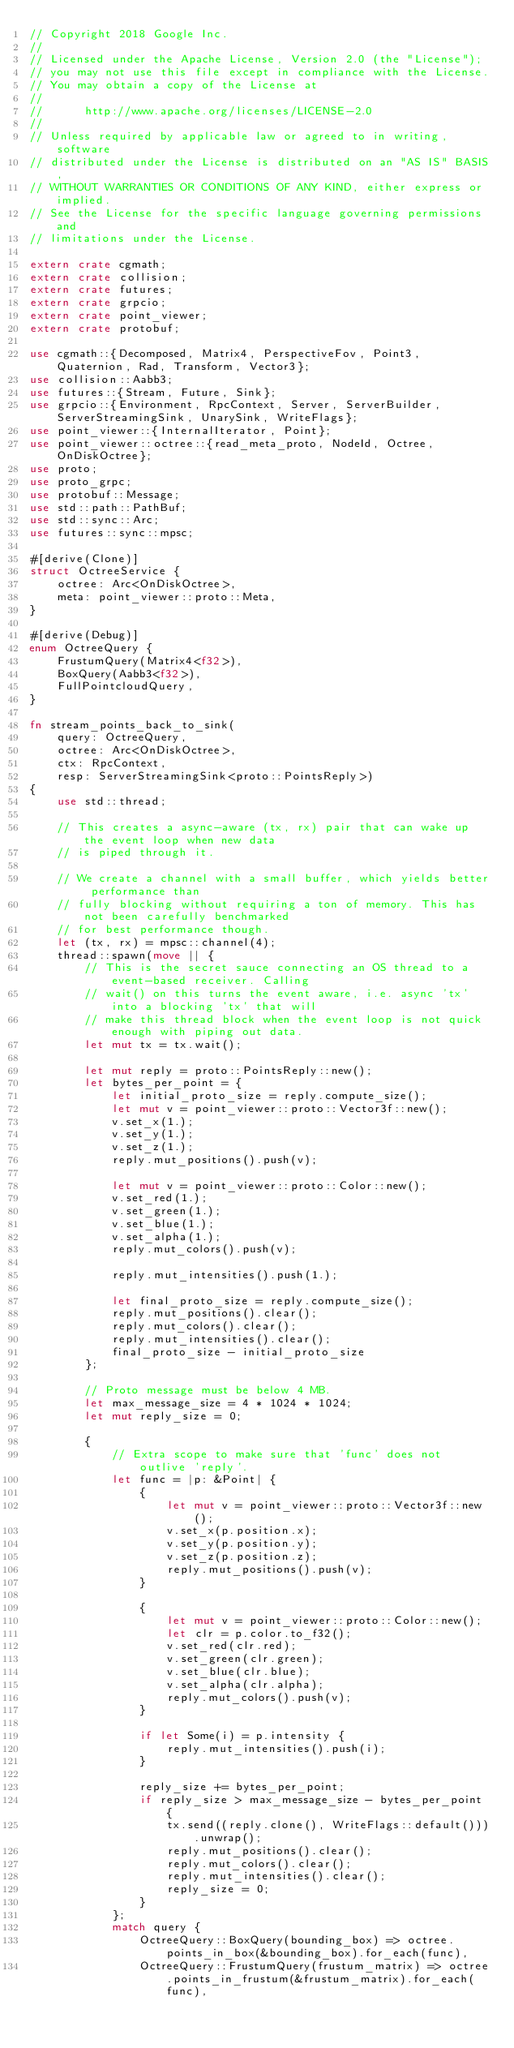<code> <loc_0><loc_0><loc_500><loc_500><_Rust_>// Copyright 2018 Google Inc.
//
// Licensed under the Apache License, Version 2.0 (the "License");
// you may not use this file except in compliance with the License.
// You may obtain a copy of the License at
//
//      http://www.apache.org/licenses/LICENSE-2.0
//
// Unless required by applicable law or agreed to in writing, software
// distributed under the License is distributed on an "AS IS" BASIS,
// WITHOUT WARRANTIES OR CONDITIONS OF ANY KIND, either express or implied.
// See the License for the specific language governing permissions and
// limitations under the License.

extern crate cgmath;
extern crate collision;
extern crate futures;
extern crate grpcio;
extern crate point_viewer;
extern crate protobuf;

use cgmath::{Decomposed, Matrix4, PerspectiveFov, Point3, Quaternion, Rad, Transform, Vector3};
use collision::Aabb3;
use futures::{Stream, Future, Sink};
use grpcio::{Environment, RpcContext, Server, ServerBuilder, ServerStreamingSink, UnarySink, WriteFlags};
use point_viewer::{InternalIterator, Point};
use point_viewer::octree::{read_meta_proto, NodeId, Octree, OnDiskOctree};
use proto;
use proto_grpc;
use protobuf::Message;
use std::path::PathBuf;
use std::sync::Arc;
use futures::sync::mpsc;

#[derive(Clone)]
struct OctreeService {
    octree: Arc<OnDiskOctree>,
    meta: point_viewer::proto::Meta,
}

#[derive(Debug)]
enum OctreeQuery {
    FrustumQuery(Matrix4<f32>),
    BoxQuery(Aabb3<f32>),
    FullPointcloudQuery,
}

fn stream_points_back_to_sink(
    query: OctreeQuery,
    octree: Arc<OnDiskOctree>,
    ctx: RpcContext,
    resp: ServerStreamingSink<proto::PointsReply>)
{
    use std::thread;

    // This creates a async-aware (tx, rx) pair that can wake up the event loop when new data
    // is piped through it.

    // We create a channel with a small buffer, which yields better performance than
    // fully blocking without requiring a ton of memory. This has not been carefully benchmarked
    // for best performance though.
    let (tx, rx) = mpsc::channel(4);
    thread::spawn(move || {
        // This is the secret sauce connecting an OS thread to a event-based receiver. Calling
        // wait() on this turns the event aware, i.e. async 'tx' into a blocking 'tx' that will
        // make this thread block when the event loop is not quick enough with piping out data.
        let mut tx = tx.wait();

        let mut reply = proto::PointsReply::new();
        let bytes_per_point = {
            let initial_proto_size = reply.compute_size();
            let mut v = point_viewer::proto::Vector3f::new();
            v.set_x(1.);
            v.set_y(1.);
            v.set_z(1.);
            reply.mut_positions().push(v);

            let mut v = point_viewer::proto::Color::new();
            v.set_red(1.);
            v.set_green(1.);
            v.set_blue(1.);
            v.set_alpha(1.);
            reply.mut_colors().push(v);

            reply.mut_intensities().push(1.);

            let final_proto_size = reply.compute_size();
            reply.mut_positions().clear();
            reply.mut_colors().clear();
            reply.mut_intensities().clear();
            final_proto_size - initial_proto_size
        };

        // Proto message must be below 4 MB.
        let max_message_size = 4 * 1024 * 1024;
        let mut reply_size = 0;

        {
            // Extra scope to make sure that 'func' does not outlive 'reply'.
            let func = |p: &Point| {
                {
                    let mut v = point_viewer::proto::Vector3f::new();
                    v.set_x(p.position.x);
                    v.set_y(p.position.y);
                    v.set_z(p.position.z);
                    reply.mut_positions().push(v);
                }

                {
                    let mut v = point_viewer::proto::Color::new();
                    let clr = p.color.to_f32();
                    v.set_red(clr.red);
                    v.set_green(clr.green);
                    v.set_blue(clr.blue);
                    v.set_alpha(clr.alpha);
                    reply.mut_colors().push(v);
                }

                if let Some(i) = p.intensity {
                    reply.mut_intensities().push(i);
                }

                reply_size += bytes_per_point;
                if reply_size > max_message_size - bytes_per_point {
                    tx.send((reply.clone(), WriteFlags::default())).unwrap();
                    reply.mut_positions().clear();
                    reply.mut_colors().clear();
                    reply.mut_intensities().clear();
                    reply_size = 0;
                }
            };
            match query {
                OctreeQuery::BoxQuery(bounding_box) => octree.points_in_box(&bounding_box).for_each(func),
                OctreeQuery::FrustumQuery(frustum_matrix) => octree.points_in_frustum(&frustum_matrix).for_each(func),</code> 